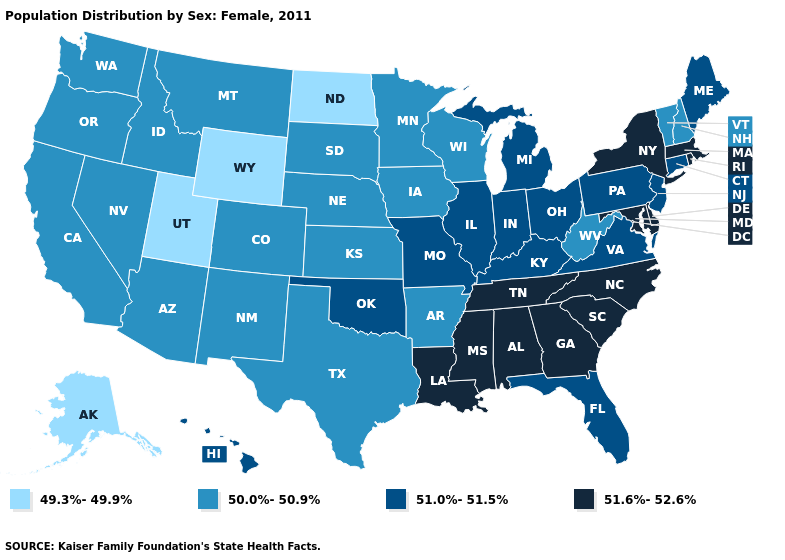Name the states that have a value in the range 51.6%-52.6%?
Concise answer only. Alabama, Delaware, Georgia, Louisiana, Maryland, Massachusetts, Mississippi, New York, North Carolina, Rhode Island, South Carolina, Tennessee. What is the lowest value in states that border Ohio?
Short answer required. 50.0%-50.9%. What is the highest value in the USA?
Give a very brief answer. 51.6%-52.6%. What is the value of Michigan?
Be succinct. 51.0%-51.5%. What is the value of Kansas?
Keep it brief. 50.0%-50.9%. What is the lowest value in the USA?
Keep it brief. 49.3%-49.9%. Does Mississippi have the highest value in the USA?
Concise answer only. Yes. What is the value of Indiana?
Keep it brief. 51.0%-51.5%. Does the first symbol in the legend represent the smallest category?
Concise answer only. Yes. Does Rhode Island have the same value as Washington?
Concise answer only. No. What is the value of Massachusetts?
Short answer required. 51.6%-52.6%. Which states hav the highest value in the South?
Give a very brief answer. Alabama, Delaware, Georgia, Louisiana, Maryland, Mississippi, North Carolina, South Carolina, Tennessee. Among the states that border Iowa , does Illinois have the highest value?
Write a very short answer. Yes. Does North Dakota have the lowest value in the MidWest?
Keep it brief. Yes. Name the states that have a value in the range 49.3%-49.9%?
Short answer required. Alaska, North Dakota, Utah, Wyoming. 